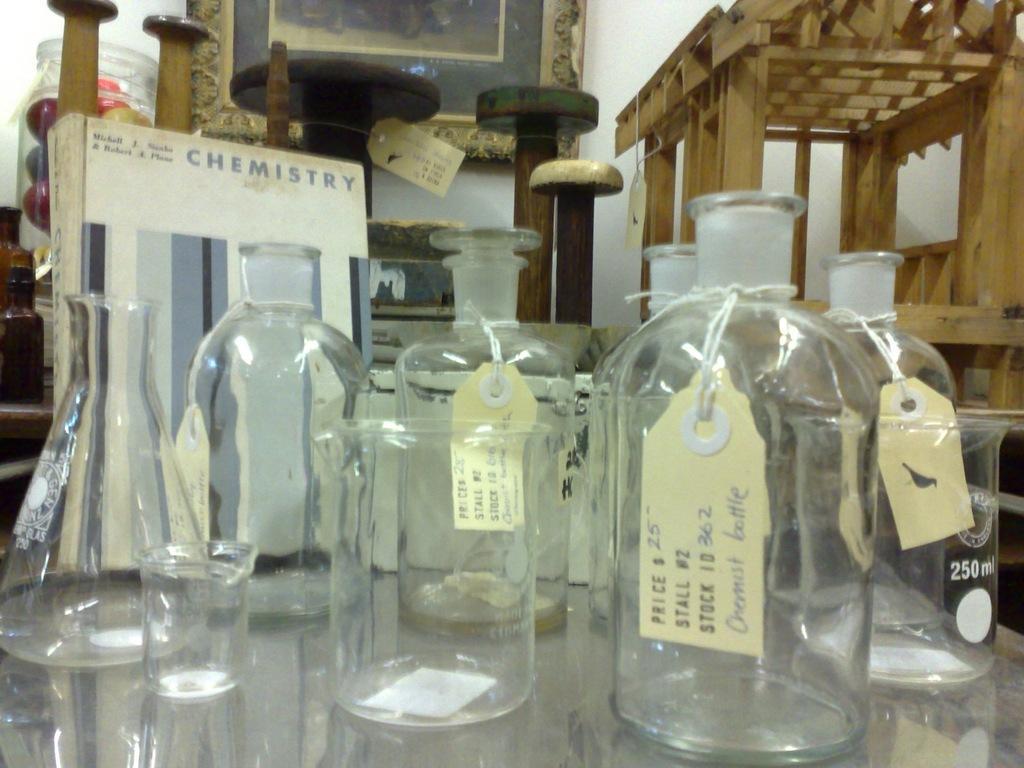Describe this image in one or two sentences. In this picture there are empty glass bottles which are kept on the table, there is a board at the left side of the image the word chemistry written on it. 